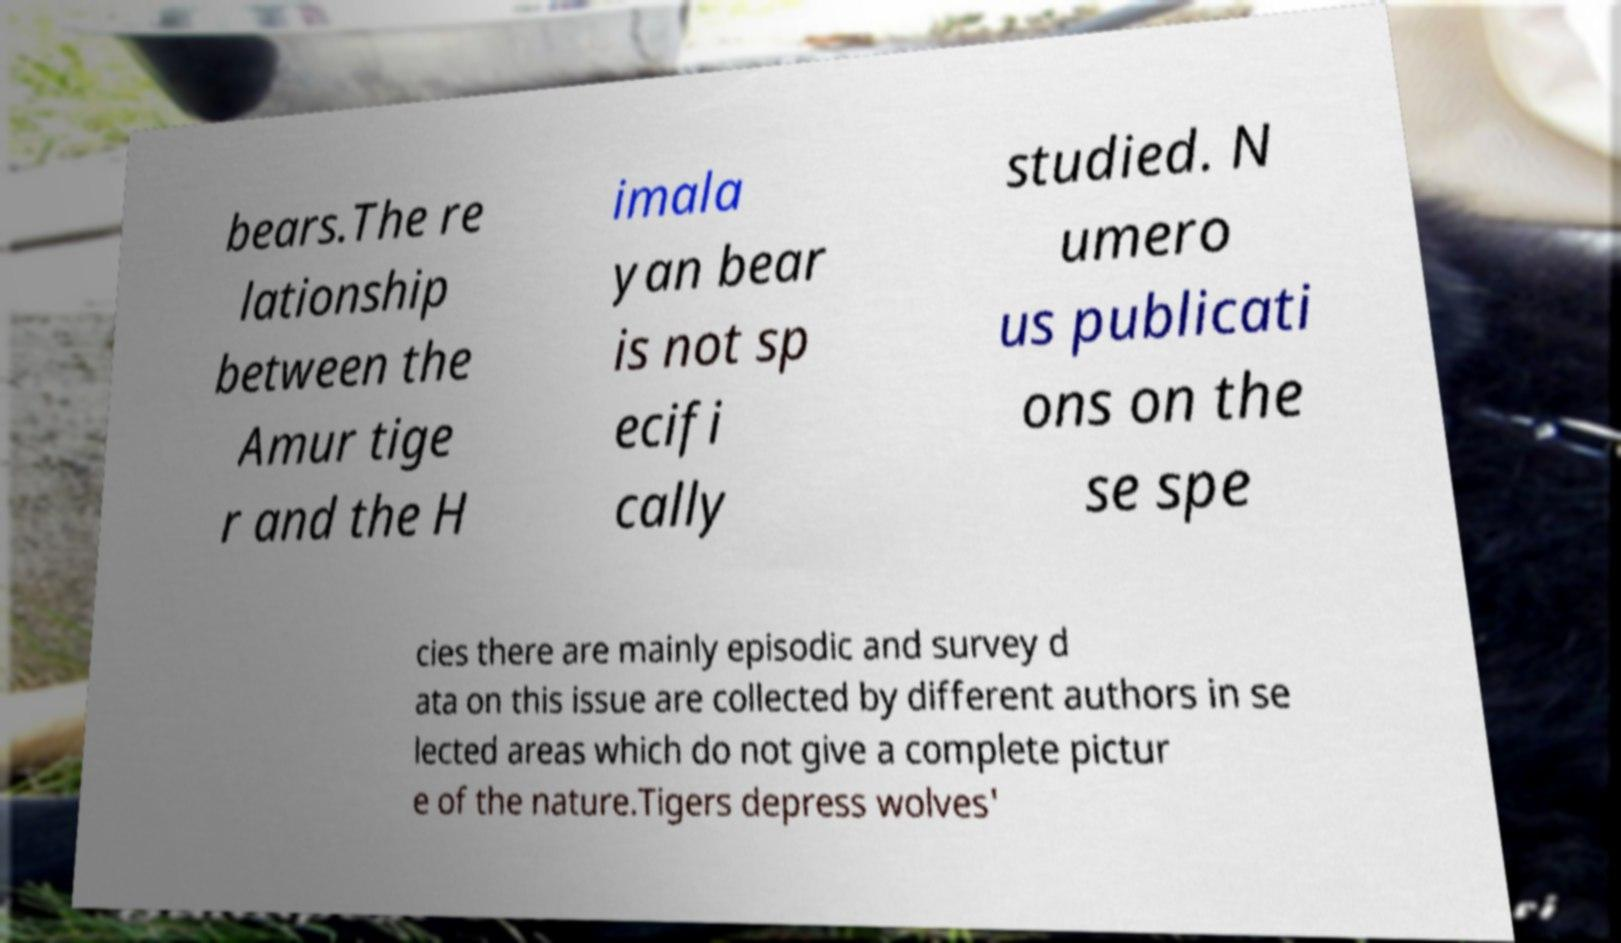Can you read and provide the text displayed in the image?This photo seems to have some interesting text. Can you extract and type it out for me? bears.The re lationship between the Amur tige r and the H imala yan bear is not sp ecifi cally studied. N umero us publicati ons on the se spe cies there are mainly episodic and survey d ata on this issue are collected by different authors in se lected areas which do not give a complete pictur e of the nature.Tigers depress wolves' 